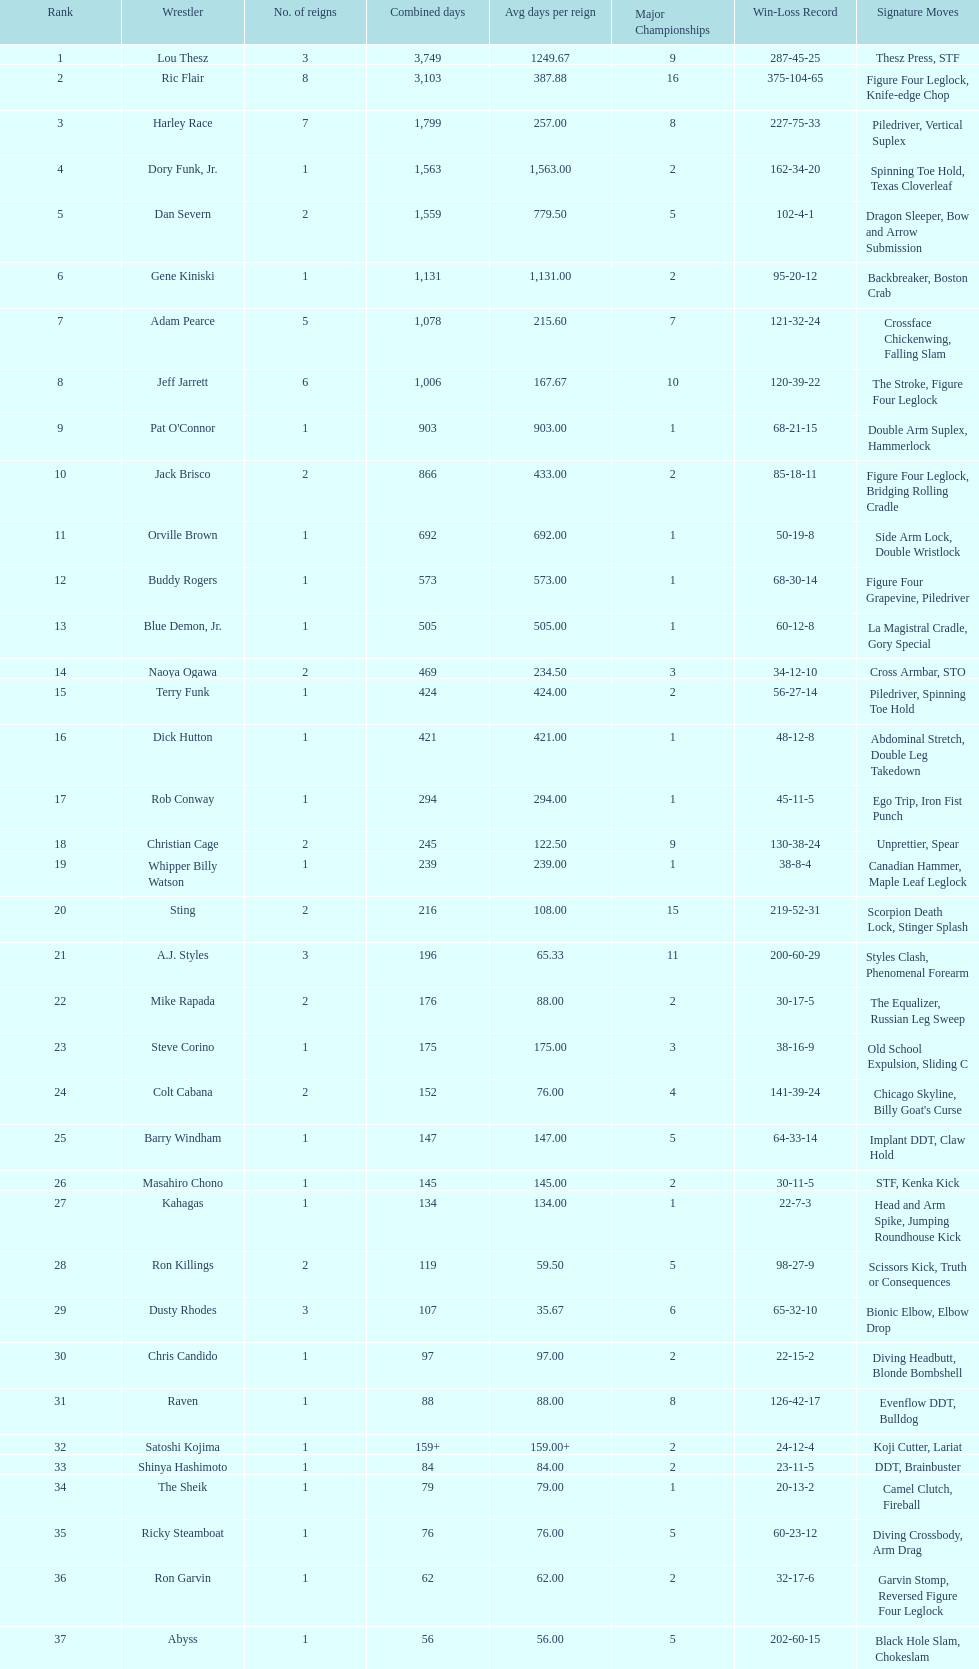Which professional wrestler has had the most number of reigns as nwa world heavyweight champion? Ric Flair. Write the full table. {'header': ['Rank', 'Wrestler', 'No. of reigns', 'Combined days', 'Avg days per reign', 'Major Championships', 'Win-Loss Record', 'Signature Moves'], 'rows': [['1', 'Lou Thesz', '3', '3,749', '1249.67', '9', '287-45-25', 'Thesz Press, STF'], ['2', 'Ric Flair', '8', '3,103', '387.88', '16', '375-104-65', 'Figure Four Leglock, Knife-edge Chop'], ['3', 'Harley Race', '7', '1,799', '257.00', '8', '227-75-33', 'Piledriver, Vertical Suplex'], ['4', 'Dory Funk, Jr.', '1', '1,563', '1,563.00', '2', '162-34-20', 'Spinning Toe Hold, Texas Cloverleaf'], ['5', 'Dan Severn', '2', '1,559', '779.50', '5', '102-4-1', 'Dragon Sleeper, Bow and Arrow Submission'], ['6', 'Gene Kiniski', '1', '1,131', '1,131.00', '2', '95-20-12', 'Backbreaker, Boston Crab'], ['7', 'Adam Pearce', '5', '1,078', '215.60', '7', '121-32-24', 'Crossface Chickenwing, Falling Slam'], ['8', 'Jeff Jarrett', '6', '1,006', '167.67', '10', '120-39-22', 'The Stroke, Figure Four Leglock'], ['9', "Pat O'Connor", '1', '903', '903.00', '1', '68-21-15', 'Double Arm Suplex, Hammerlock'], ['10', 'Jack Brisco', '2', '866', '433.00', '2', '85-18-11', 'Figure Four Leglock, Bridging Rolling Cradle'], ['11', 'Orville Brown', '1', '692', '692.00', '1', '50-19-8', 'Side Arm Lock, Double Wristlock'], ['12', 'Buddy Rogers', '1', '573', '573.00', '1', '68-30-14', 'Figure Four Grapevine, Piledriver'], ['13', 'Blue Demon, Jr.', '1', '505', '505.00', '1', '60-12-8', 'La Magistral Cradle, Gory Special'], ['14', 'Naoya Ogawa', '2', '469', '234.50', '3', '34-12-10', 'Cross Armbar, STO'], ['15', 'Terry Funk', '1', '424', '424.00', '2', '56-27-14', 'Piledriver, Spinning Toe Hold'], ['16', 'Dick Hutton', '1', '421', '421.00', '1', '48-12-8', 'Abdominal Stretch, Double Leg Takedown'], ['17', 'Rob Conway', '1', '294', '294.00', '1', '45-11-5', 'Ego Trip, Iron Fist Punch'], ['18', 'Christian Cage', '2', '245', '122.50', '9', '130-38-24', 'Unprettier, Spear'], ['19', 'Whipper Billy Watson', '1', '239', '239.00', '1', '38-8-4', 'Canadian Hammer, Maple Leaf Leglock'], ['20', 'Sting', '2', '216', '108.00', '15', '219-52-31', 'Scorpion Death Lock, Stinger Splash'], ['21', 'A.J. Styles', '3', '196', '65.33', '11', '200-60-29', 'Styles Clash, Phenomenal Forearm'], ['22', 'Mike Rapada', '2', '176', '88.00', '2', '30-17-5', 'The Equalizer, Russian Leg Sweep'], ['23', 'Steve Corino', '1', '175', '175.00', '3', '38-16-9', 'Old School Expulsion, Sliding C'], ['24', 'Colt Cabana', '2', '152', '76.00', '4', '141-39-24', "Chicago Skyline, Billy Goat's Curse"], ['25', 'Barry Windham', '1', '147', '147.00', '5', '64-33-14', 'Implant DDT, Claw Hold'], ['26', 'Masahiro Chono', '1', '145', '145.00', '2', '30-11-5', 'STF, Kenka Kick'], ['27', 'Kahagas', '1', '134', '134.00', '1', '22-7-3', 'Head and Arm Spike, Jumping Roundhouse Kick'], ['28', 'Ron Killings', '2', '119', '59.50', '5', '98-27-9', 'Scissors Kick, Truth or Consequences'], ['29', 'Dusty Rhodes', '3', '107', '35.67', '6', '65-32-10', 'Bionic Elbow, Elbow Drop'], ['30', 'Chris Candido', '1', '97', '97.00', '2', '22-15-2', 'Diving Headbutt, Blonde Bombshell'], ['31', 'Raven', '1', '88', '88.00', '8', '126-42-17', 'Evenflow DDT, Bulldog'], ['32', 'Satoshi Kojima', '1', '159+', '159.00+', '2', '24-12-4', 'Koji Cutter, Lariat'], ['33', 'Shinya Hashimoto', '1', '84', '84.00', '2', '23-11-5', 'DDT, Brainbuster'], ['34', 'The Sheik', '1', '79', '79.00', '1', '20-13-2', 'Camel Clutch, Fireball'], ['35', 'Ricky Steamboat', '1', '76', '76.00', '5', '60-23-12', 'Diving Crossbody, Arm Drag'], ['36', 'Ron Garvin', '1', '62', '62.00', '2', '32-17-6', 'Garvin Stomp, Reversed Figure Four Leglock'], ['37', 'Abyss', '1', '56', '56.00', '5', '202-60-15', 'Black Hole Slam, Chokeslam'], ['39', 'Ken Shamrock', '1', '49', '49.00', '3', '24-13-4', 'Ankle Lock, Belly-to-belly Suplex'], ['39', 'Brent Albright', '1', '49', '49.00', '1', '20-14-3', 'Half Nelson Suplex, Crowbar'], ['40', 'The Great Muta', '1', '48', '48.00', '8', '89-22-13', 'Shining Wizard, Moonsault'], ['41', 'Sabu', '1', '38', '38.00', '5', '99-45-17', 'Triple Jump Moonsault, Arabian Facebuster'], ['42', 'Giant Baba', '3', '19', '6.33', '6', '68-23-9', 'Russian Bear Hug, Baba Chop'], ['43', 'Kerry Von Erich', '1', '18', '18.00', '1', '12-8-1', 'Iron Claw, Tornado Punch'], ['44', 'Gary Steele', '1', '7', '7.00', '1', '3-2-1', 'Tower of London, Tiger Bomb'], ['45', 'Tommy Rich', '1', '4', '4.00', '3', '21-14-7', 'Thesz Press, Lou Thesz Press'], ['46', 'Rhino', '1', '2', '2.00', '4', '41-23-6', 'Gore, Piledriver'], ['47', 'Shane Douglas', '1', '<1', '<1.00', '4', '45-34-9', 'Belly-to-Belly Suplex, Pittsburgh Plunge']]} 